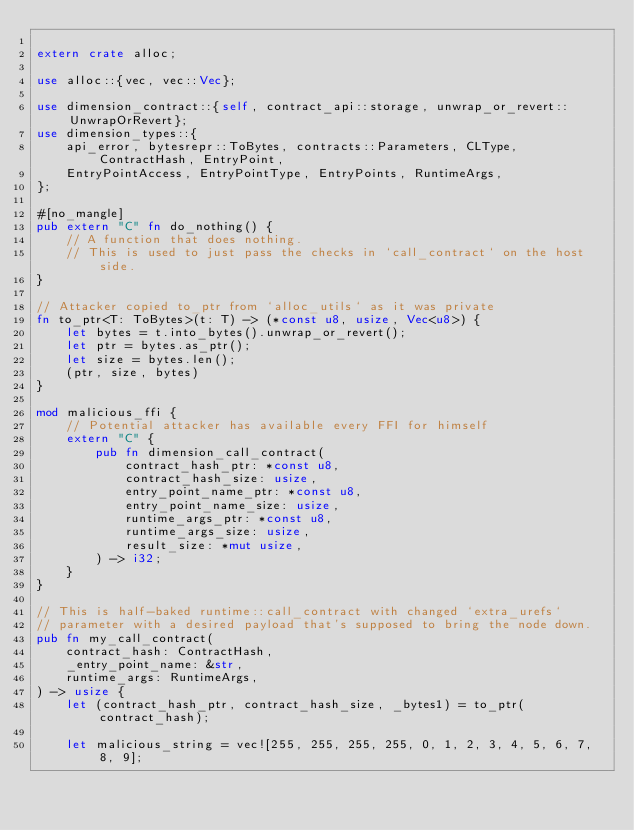Convert code to text. <code><loc_0><loc_0><loc_500><loc_500><_Rust_>
extern crate alloc;

use alloc::{vec, vec::Vec};

use dimension_contract::{self, contract_api::storage, unwrap_or_revert::UnwrapOrRevert};
use dimension_types::{
    api_error, bytesrepr::ToBytes, contracts::Parameters, CLType, ContractHash, EntryPoint,
    EntryPointAccess, EntryPointType, EntryPoints, RuntimeArgs,
};

#[no_mangle]
pub extern "C" fn do_nothing() {
    // A function that does nothing.
    // This is used to just pass the checks in `call_contract` on the host side.
}

// Attacker copied to_ptr from `alloc_utils` as it was private
fn to_ptr<T: ToBytes>(t: T) -> (*const u8, usize, Vec<u8>) {
    let bytes = t.into_bytes().unwrap_or_revert();
    let ptr = bytes.as_ptr();
    let size = bytes.len();
    (ptr, size, bytes)
}

mod malicious_ffi {
    // Potential attacker has available every FFI for himself
    extern "C" {
        pub fn dimension_call_contract(
            contract_hash_ptr: *const u8,
            contract_hash_size: usize,
            entry_point_name_ptr: *const u8,
            entry_point_name_size: usize,
            runtime_args_ptr: *const u8,
            runtime_args_size: usize,
            result_size: *mut usize,
        ) -> i32;
    }
}

// This is half-baked runtime::call_contract with changed `extra_urefs`
// parameter with a desired payload that's supposed to bring the node down.
pub fn my_call_contract(
    contract_hash: ContractHash,
    _entry_point_name: &str,
    runtime_args: RuntimeArgs,
) -> usize {
    let (contract_hash_ptr, contract_hash_size, _bytes1) = to_ptr(contract_hash);

    let malicious_string = vec![255, 255, 255, 255, 0, 1, 2, 3, 4, 5, 6, 7, 8, 9];
</code> 